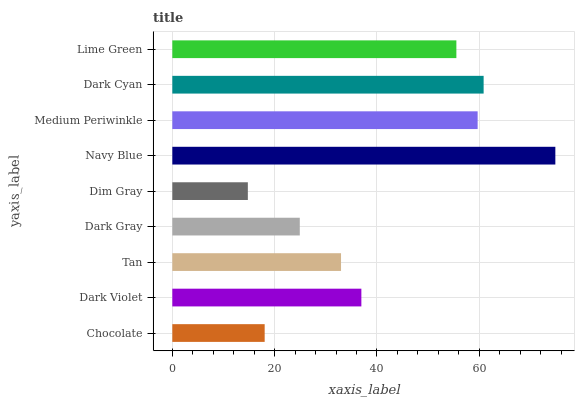Is Dim Gray the minimum?
Answer yes or no. Yes. Is Navy Blue the maximum?
Answer yes or no. Yes. Is Dark Violet the minimum?
Answer yes or no. No. Is Dark Violet the maximum?
Answer yes or no. No. Is Dark Violet greater than Chocolate?
Answer yes or no. Yes. Is Chocolate less than Dark Violet?
Answer yes or no. Yes. Is Chocolate greater than Dark Violet?
Answer yes or no. No. Is Dark Violet less than Chocolate?
Answer yes or no. No. Is Dark Violet the high median?
Answer yes or no. Yes. Is Dark Violet the low median?
Answer yes or no. Yes. Is Navy Blue the high median?
Answer yes or no. No. Is Dim Gray the low median?
Answer yes or no. No. 